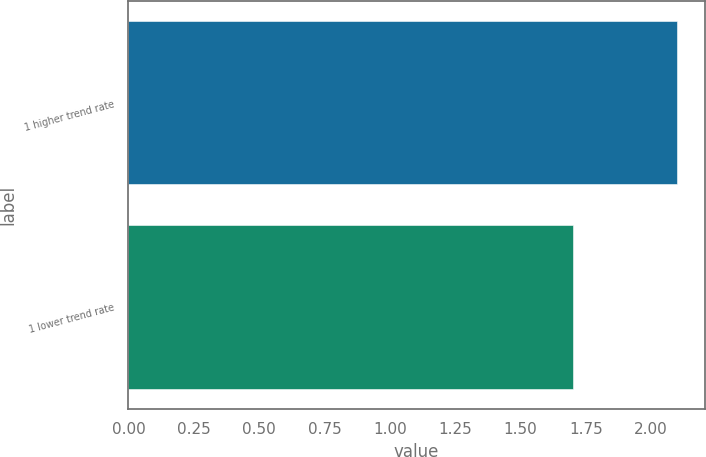Convert chart to OTSL. <chart><loc_0><loc_0><loc_500><loc_500><bar_chart><fcel>1 higher trend rate<fcel>1 lower trend rate<nl><fcel>2.1<fcel>1.7<nl></chart> 